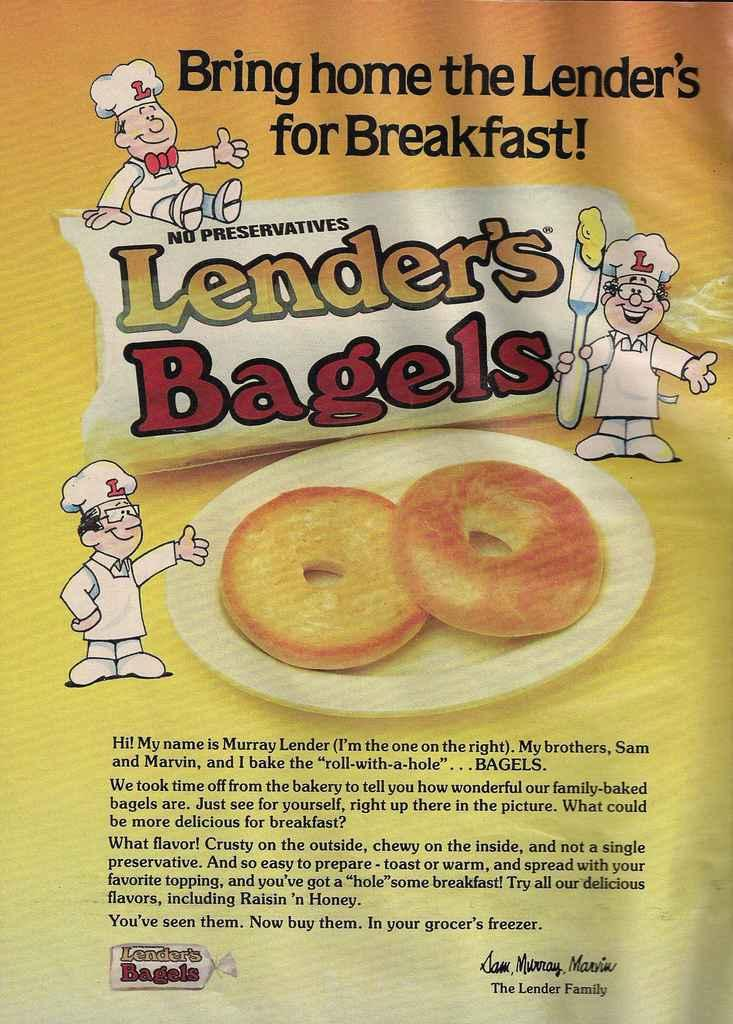What can be seen in the image in the image? There is a poster in the image. What is featured on the poster? There is text on the poster. What type of cap is being worn by the person in the image? There is no person present in the image, only a poster with text. 